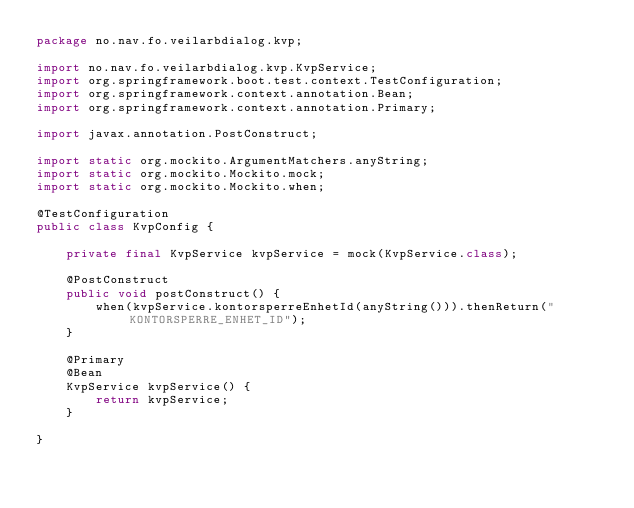<code> <loc_0><loc_0><loc_500><loc_500><_Java_>package no.nav.fo.veilarbdialog.kvp;

import no.nav.fo.veilarbdialog.kvp.KvpService;
import org.springframework.boot.test.context.TestConfiguration;
import org.springframework.context.annotation.Bean;
import org.springframework.context.annotation.Primary;

import javax.annotation.PostConstruct;

import static org.mockito.ArgumentMatchers.anyString;
import static org.mockito.Mockito.mock;
import static org.mockito.Mockito.when;

@TestConfiguration
public class KvpConfig {

    private final KvpService kvpService = mock(KvpService.class);

    @PostConstruct
    public void postConstruct() {
        when(kvpService.kontorsperreEnhetId(anyString())).thenReturn("KONTORSPERRE_ENHET_ID");
    }

    @Primary
    @Bean
    KvpService kvpService() {
        return kvpService;
    }

}
</code> 